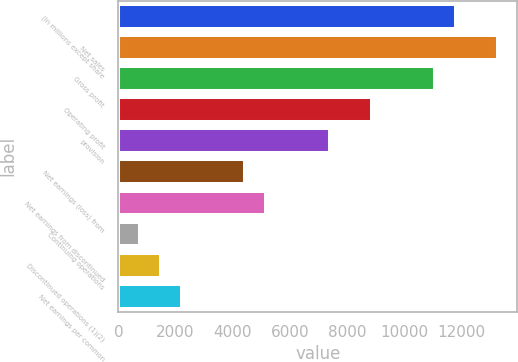Convert chart to OTSL. <chart><loc_0><loc_0><loc_500><loc_500><bar_chart><fcel>(In millions except share<fcel>Net sales<fcel>Gross profit<fcel>Operating profit<fcel>provision<fcel>Net earnings (loss) from<fcel>Net earnings from discontinued<fcel>Continuing operations<fcel>Discontinued operations (1)(2)<fcel>Net earnings per common<nl><fcel>11831.9<fcel>13310.8<fcel>11092.4<fcel>8874.04<fcel>7395.12<fcel>4437.28<fcel>5176.74<fcel>739.98<fcel>1479.44<fcel>2218.9<nl></chart> 